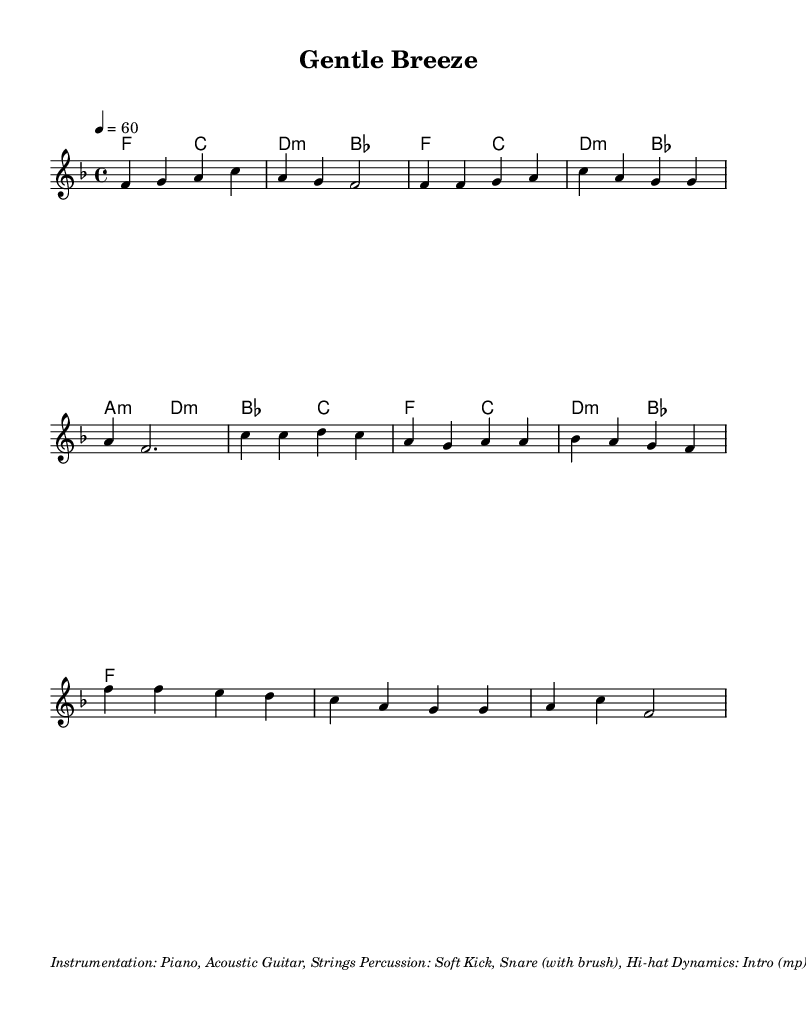What is the key signature of this music? The key signature indicates that there are one flat note (B) in the music, which corresponds to F major since the music is written in F major, as stated at the beginning of the global declaration.
Answer: F major What is the time signature of this music? The time signature is indicated at the beginning of the score as 4/4, meaning there are four beats in a measure and each beat is a quarter note.
Answer: 4/4 What is the tempo marking of this piece? The tempo marking shows 4 = 60, which means there are 60 beats per minute, indicating a slow and relaxed tempo appropriate for a ballad.
Answer: 60 What is the texture of the composition likely to be? The instrumentation section describes the texture as featuring piano, acoustic guitar, and strings with light percussion, contributing to a soft and relaxing ambiance typical of K-Pop ballads.
Answer: Soft How many sections are present in this piece? Analyzing the score, there are four distinct sections: Intro, Verse, Pre-Chorus, and Chorus, which is common in K-Pop structure for building emotional dynamics.
Answer: Four What dynamics are specified for the Intro section? The dynamics indicate that for the Intro, the music is marked as "mp," which stands for mezzo-piano, indicating a moderately soft volume level, suitable for establishing a gentle beginning.
Answer: mp 